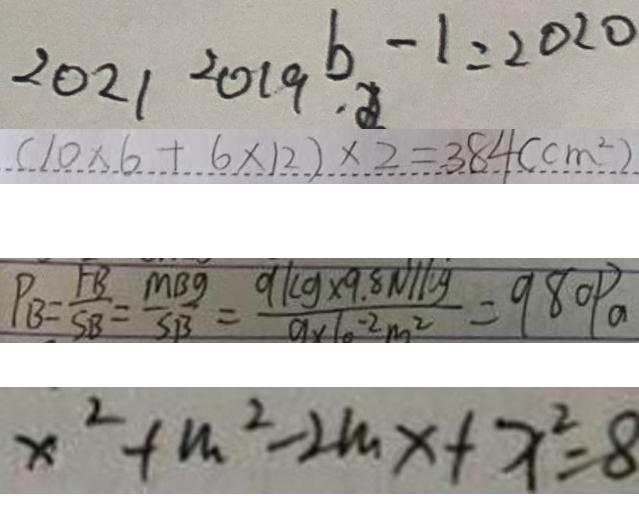<formula> <loc_0><loc_0><loc_500><loc_500>2 0 2 1 2 0 1 9 b - 1 = 2 0 2 0 
 ( 1 0 \times 6 + 6 \times 1 2 ) \times 2 = 3 8 4 ( c m ^ { 2 } ) 
 P _ { B } = \frac { F B } { S B } = \frac { M B g } { S B } = \frac { 9 / k g \times 9 . 8 N / k g } { 9 \times 1 0 ^ { - 2 } m ^ { 2 } } = 9 8 0 P a 
 x ^ { 2 } + m ^ { 2 } - 2 m x + x ^ { 2 } = 8</formula> 